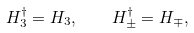<formula> <loc_0><loc_0><loc_500><loc_500>H _ { 3 } ^ { \dagger } = H _ { 3 } , \quad H _ { \pm } ^ { \dagger } = H _ { \mp } ,</formula> 